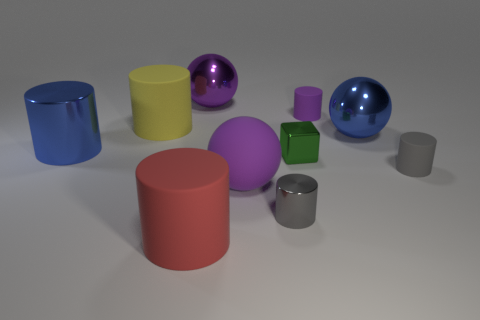What size is the rubber object that is the same color as the tiny metal cylinder? The rubber object that shares its color with the tiny metal cylinder is medium-sized compared to other objects in the image. It appears to be a cylindrical shape with a matte finish, suggesting it might be made of rubber. 